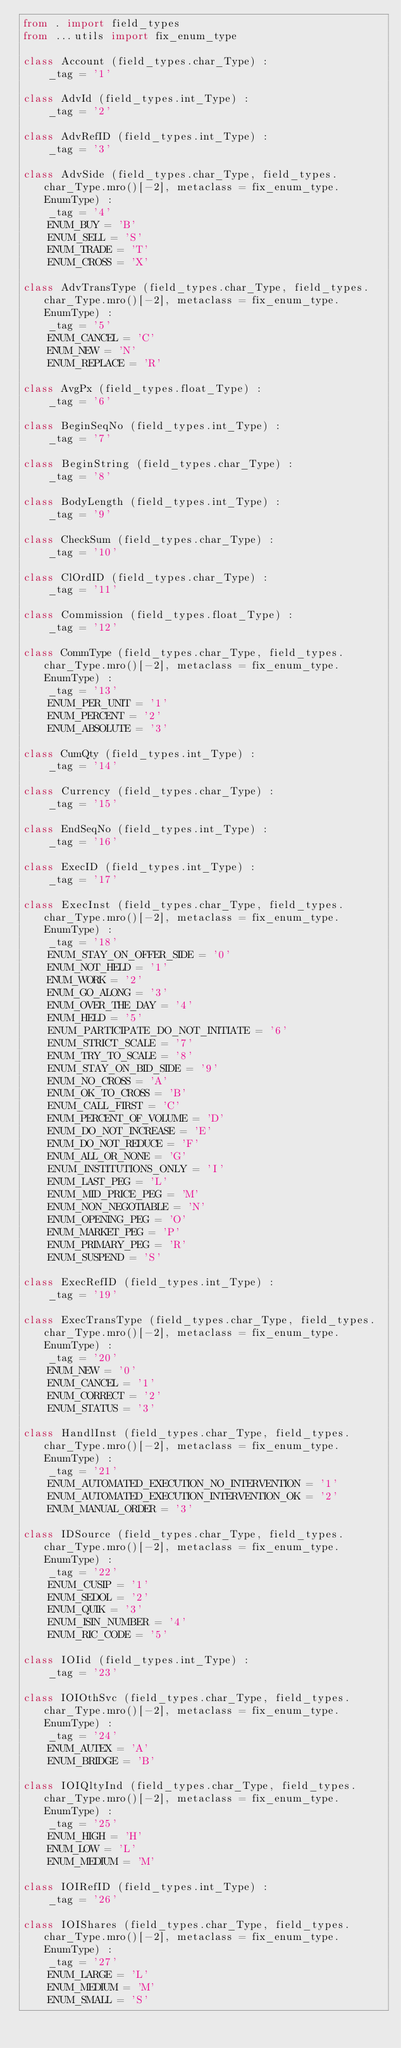<code> <loc_0><loc_0><loc_500><loc_500><_Python_>from . import field_types
from ...utils import fix_enum_type

class Account (field_types.char_Type) :
    _tag = '1'

class AdvId (field_types.int_Type) :
    _tag = '2'

class AdvRefID (field_types.int_Type) :
    _tag = '3'

class AdvSide (field_types.char_Type, field_types.char_Type.mro()[-2], metaclass = fix_enum_type.EnumType) :
    _tag = '4'
    ENUM_BUY = 'B'
    ENUM_SELL = 'S'
    ENUM_TRADE = 'T'
    ENUM_CROSS = 'X'

class AdvTransType (field_types.char_Type, field_types.char_Type.mro()[-2], metaclass = fix_enum_type.EnumType) :
    _tag = '5'
    ENUM_CANCEL = 'C'
    ENUM_NEW = 'N'
    ENUM_REPLACE = 'R'

class AvgPx (field_types.float_Type) :
    _tag = '6'

class BeginSeqNo (field_types.int_Type) :
    _tag = '7'

class BeginString (field_types.char_Type) :
    _tag = '8'

class BodyLength (field_types.int_Type) :
    _tag = '9'

class CheckSum (field_types.char_Type) :
    _tag = '10'

class ClOrdID (field_types.char_Type) :
    _tag = '11'

class Commission (field_types.float_Type) :
    _tag = '12'

class CommType (field_types.char_Type, field_types.char_Type.mro()[-2], metaclass = fix_enum_type.EnumType) :
    _tag = '13'
    ENUM_PER_UNIT = '1'
    ENUM_PERCENT = '2'
    ENUM_ABSOLUTE = '3'

class CumQty (field_types.int_Type) :
    _tag = '14'

class Currency (field_types.char_Type) :
    _tag = '15'

class EndSeqNo (field_types.int_Type) :
    _tag = '16'

class ExecID (field_types.int_Type) :
    _tag = '17'

class ExecInst (field_types.char_Type, field_types.char_Type.mro()[-2], metaclass = fix_enum_type.EnumType) :
    _tag = '18'
    ENUM_STAY_ON_OFFER_SIDE = '0'
    ENUM_NOT_HELD = '1'
    ENUM_WORK = '2'
    ENUM_GO_ALONG = '3'
    ENUM_OVER_THE_DAY = '4'
    ENUM_HELD = '5'
    ENUM_PARTICIPATE_DO_NOT_INITIATE = '6'
    ENUM_STRICT_SCALE = '7'
    ENUM_TRY_TO_SCALE = '8'
    ENUM_STAY_ON_BID_SIDE = '9'
    ENUM_NO_CROSS = 'A'
    ENUM_OK_TO_CROSS = 'B'
    ENUM_CALL_FIRST = 'C'
    ENUM_PERCENT_OF_VOLUME = 'D'
    ENUM_DO_NOT_INCREASE = 'E'
    ENUM_DO_NOT_REDUCE = 'F'
    ENUM_ALL_OR_NONE = 'G'
    ENUM_INSTITUTIONS_ONLY = 'I'
    ENUM_LAST_PEG = 'L'
    ENUM_MID_PRICE_PEG = 'M'
    ENUM_NON_NEGOTIABLE = 'N'
    ENUM_OPENING_PEG = 'O'
    ENUM_MARKET_PEG = 'P'
    ENUM_PRIMARY_PEG = 'R'
    ENUM_SUSPEND = 'S'

class ExecRefID (field_types.int_Type) :
    _tag = '19'

class ExecTransType (field_types.char_Type, field_types.char_Type.mro()[-2], metaclass = fix_enum_type.EnumType) :
    _tag = '20'
    ENUM_NEW = '0'
    ENUM_CANCEL = '1'
    ENUM_CORRECT = '2'
    ENUM_STATUS = '3'

class HandlInst (field_types.char_Type, field_types.char_Type.mro()[-2], metaclass = fix_enum_type.EnumType) :
    _tag = '21'
    ENUM_AUTOMATED_EXECUTION_NO_INTERVENTION = '1'
    ENUM_AUTOMATED_EXECUTION_INTERVENTION_OK = '2'
    ENUM_MANUAL_ORDER = '3'

class IDSource (field_types.char_Type, field_types.char_Type.mro()[-2], metaclass = fix_enum_type.EnumType) :
    _tag = '22'
    ENUM_CUSIP = '1'
    ENUM_SEDOL = '2'
    ENUM_QUIK = '3'
    ENUM_ISIN_NUMBER = '4'
    ENUM_RIC_CODE = '5'

class IOIid (field_types.int_Type) :
    _tag = '23'

class IOIOthSvc (field_types.char_Type, field_types.char_Type.mro()[-2], metaclass = fix_enum_type.EnumType) :
    _tag = '24'
    ENUM_AUTEX = 'A'
    ENUM_BRIDGE = 'B'

class IOIQltyInd (field_types.char_Type, field_types.char_Type.mro()[-2], metaclass = fix_enum_type.EnumType) :
    _tag = '25'
    ENUM_HIGH = 'H'
    ENUM_LOW = 'L'
    ENUM_MEDIUM = 'M'

class IOIRefID (field_types.int_Type) :
    _tag = '26'

class IOIShares (field_types.char_Type, field_types.char_Type.mro()[-2], metaclass = fix_enum_type.EnumType) :
    _tag = '27'
    ENUM_LARGE = 'L'
    ENUM_MEDIUM = 'M'
    ENUM_SMALL = 'S'
</code> 